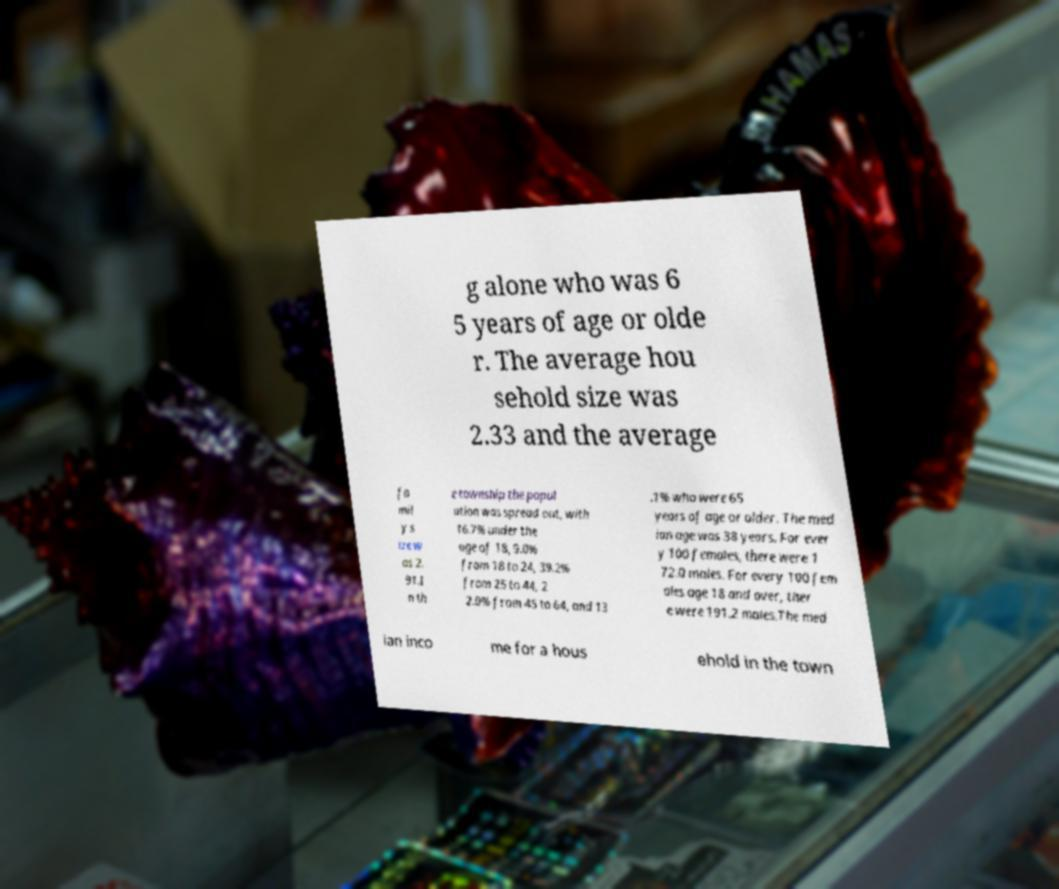Could you extract and type out the text from this image? g alone who was 6 5 years of age or olde r. The average hou sehold size was 2.33 and the average fa mil y s ize w as 2. 91.I n th e township the popul ation was spread out, with 16.7% under the age of 18, 9.0% from 18 to 24, 39.2% from 25 to 44, 2 2.0% from 45 to 64, and 13 .1% who were 65 years of age or older. The med ian age was 38 years. For ever y 100 females, there were 1 72.0 males. For every 100 fem ales age 18 and over, ther e were 191.2 males.The med ian inco me for a hous ehold in the town 